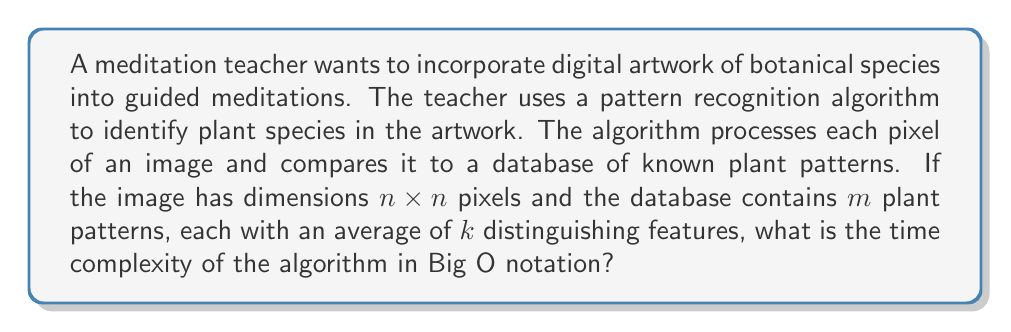Can you solve this math problem? To solve this problem, let's break down the algorithm's process:

1. The algorithm processes each pixel of the image:
   - The image has dimensions $n \times n$, so there are $n^2$ pixels in total.
   - This step has a time complexity of $O(n^2)$.

2. For each pixel, the algorithm compares it to all plant patterns in the database:
   - There are $m$ plant patterns in the database.
   - Each comparison involves checking $k$ distinguishing features on average.
   - This step has a time complexity of $O(m \cdot k)$ for each pixel.

3. Combining steps 1 and 2:
   - For each of the $n^2$ pixels, we perform $m \cdot k$ comparisons.
   - The total time complexity is therefore $O(n^2 \cdot m \cdot k)$.

4. In Big O notation, we typically express the complexity in terms of the input size. In this case, the input size is primarily determined by the image dimensions $n$.
   - We can consider $m$ and $k$ as constants, as they are properties of the database and not the input image.
   - Therefore, we can simplify the expression to $O(n^2)$.

However, if we want to express the complexity in terms of all variables, we would keep the full expression $O(n^2 \cdot m \cdot k)$.
Answer: The time complexity of the algorithm is $O(n^2)$, where $n$ is the width (or height) of the square image. If considering all variables, it can be expressed as $O(n^2 \cdot m \cdot k)$. 